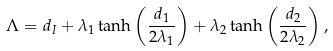Convert formula to latex. <formula><loc_0><loc_0><loc_500><loc_500>\Lambda = d _ { I } + \lambda _ { 1 } \tanh \left ( \frac { d _ { 1 } } { 2 \lambda _ { 1 } } \right ) + \lambda _ { 2 } \tanh \left ( \frac { d _ { 2 } } { 2 \lambda _ { 2 } } \right ) ,</formula> 